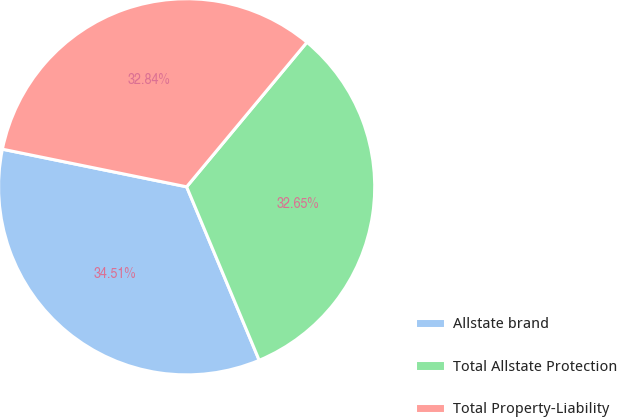Convert chart to OTSL. <chart><loc_0><loc_0><loc_500><loc_500><pie_chart><fcel>Allstate brand<fcel>Total Allstate Protection<fcel>Total Property-Liability<nl><fcel>34.51%<fcel>32.65%<fcel>32.84%<nl></chart> 